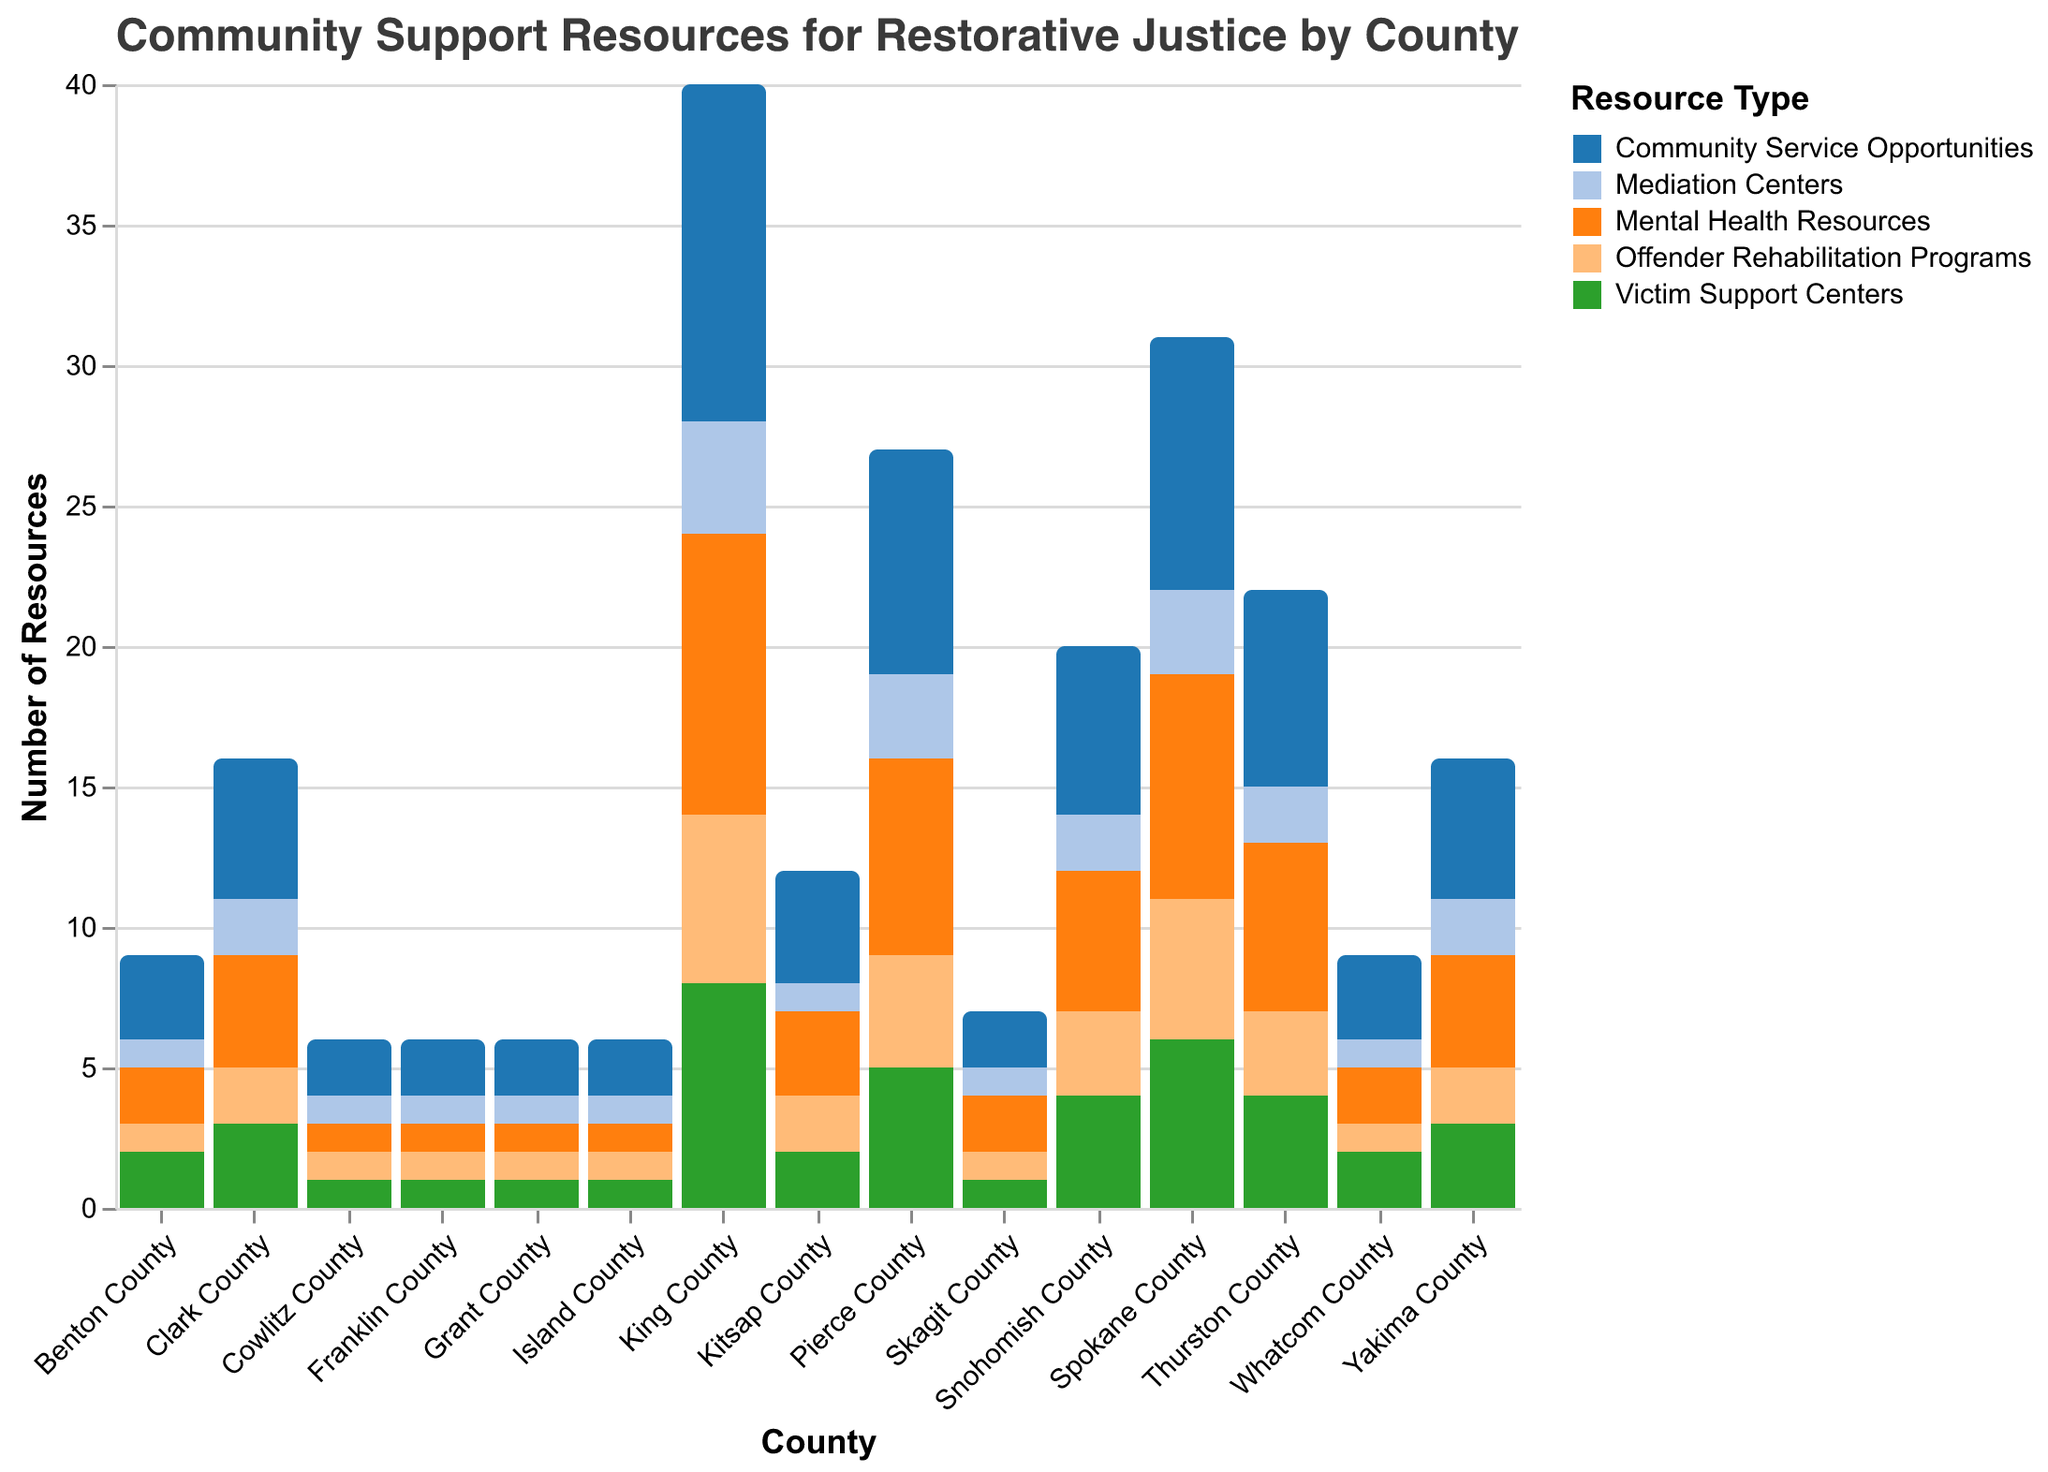Which county has the highest number of Victim Support Centers? Look for the county with the tallest bar in the "Victim Support Centers" color. King County has the highest value, which is 8.
Answer: King County Which county offers the most Community Service Opportunities? Identify the bar representing "Community Service Opportunities" and find the county with the highest value. King County has the most with a value of 12.
Answer: King County How many Offender Rehabilitation Programs are available in total across all counties? Sum all the values from the "Offender Rehabilitation Programs" category: 6 + 4 + 3 + 5 + 2 + 3 + 2 + 2 + 1 + 1 + 1 + 1 + 1 + 1 + 1 = 34.
Answer: 34 What is the average number of Mediation Centers per county? Sum the values of "Mediation Centers" across all counties and divide by the number of counties. Calculation: (4+3+2+3+2+2+1+2+1+1+1+1+1+1+1) / 15 = 1.87 (approx).
Answer: 1.87 Which county has the fewest Mental Health Resources? Identify the bar representing "Mental Health Resources" and find the county with the lowest value. Several counties (Cowlitz, Grant, Franklin, Island) have the lowest, which is 1.
Answer: Cowlitz County, Grant County, Franklin County, Island County How does the number of Community Service Opportunities in Pierce County compare to Thurston County? Compare the values represented by bars for "Community Service Opportunities" in Pierce County (8) and Thurston County (7). Pierce County has more Community Service Opportunities than Thurston County.
Answer: Pierce County > Thurston County What is the ratio of Victim Support Centers to Mental Health Resources in Spokane County? Divide the number of Victim Support Centers (6) by the number of Mental Health Resources (8). The ratio is 6:8 or 3:4.
Answer: 3:4 Which county has more Mediation Centers: Clark or Yakima? Compare the values represented by the bars for Mediation Centers in Clark County (2) and Yakima County (2). Both counties have the same number of Mediation Centers.
Answer: Equal How many counties have more than 3 Victim Support Centers? Count the number of counties where the value for Victim Support Centers is greater than 3. These are King (8), Pierce (5), Spokane (6), and Thurston (4), making a total of 4 counties.
Answer: 4 What is the sum of all Community Service Opportunities in Yakima, Whatcom, and Benton counties? Add the values for "Community Service Opportunities" in Yakima (5), Whatcom (3), and Benton (3). The sum is 5 + 3 + 3 = 11.
Answer: 11 